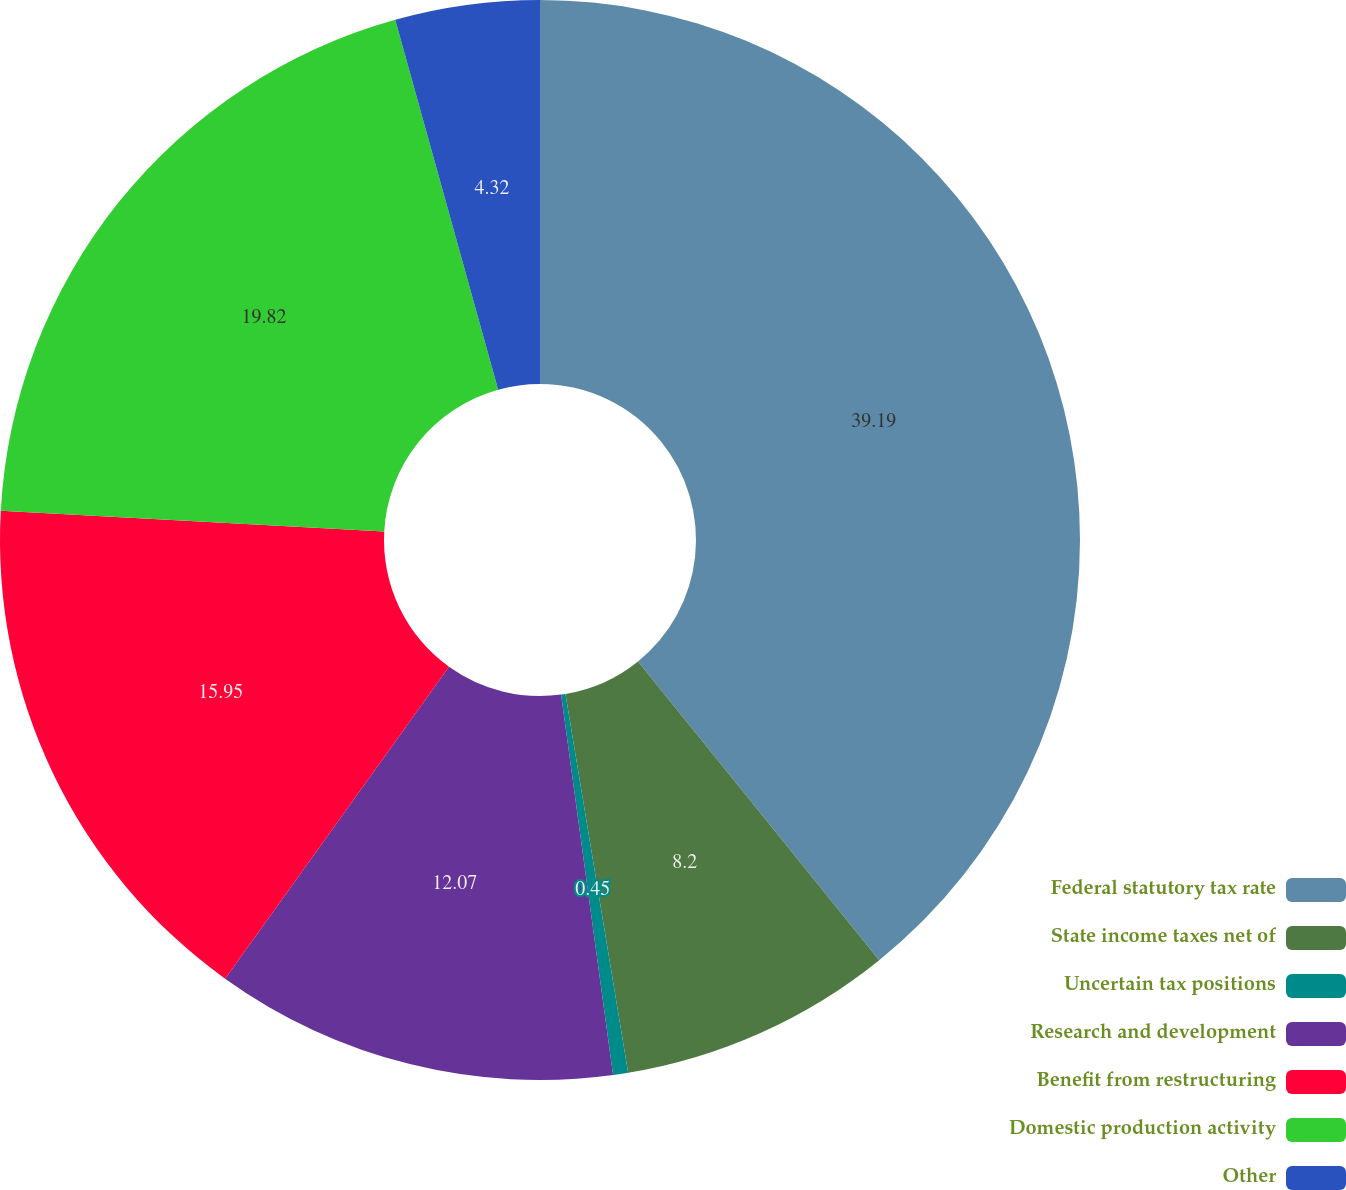<chart> <loc_0><loc_0><loc_500><loc_500><pie_chart><fcel>Federal statutory tax rate<fcel>State income taxes net of<fcel>Uncertain tax positions<fcel>Research and development<fcel>Benefit from restructuring<fcel>Domestic production activity<fcel>Other<nl><fcel>39.19%<fcel>8.2%<fcel>0.45%<fcel>12.07%<fcel>15.95%<fcel>19.82%<fcel>4.32%<nl></chart> 